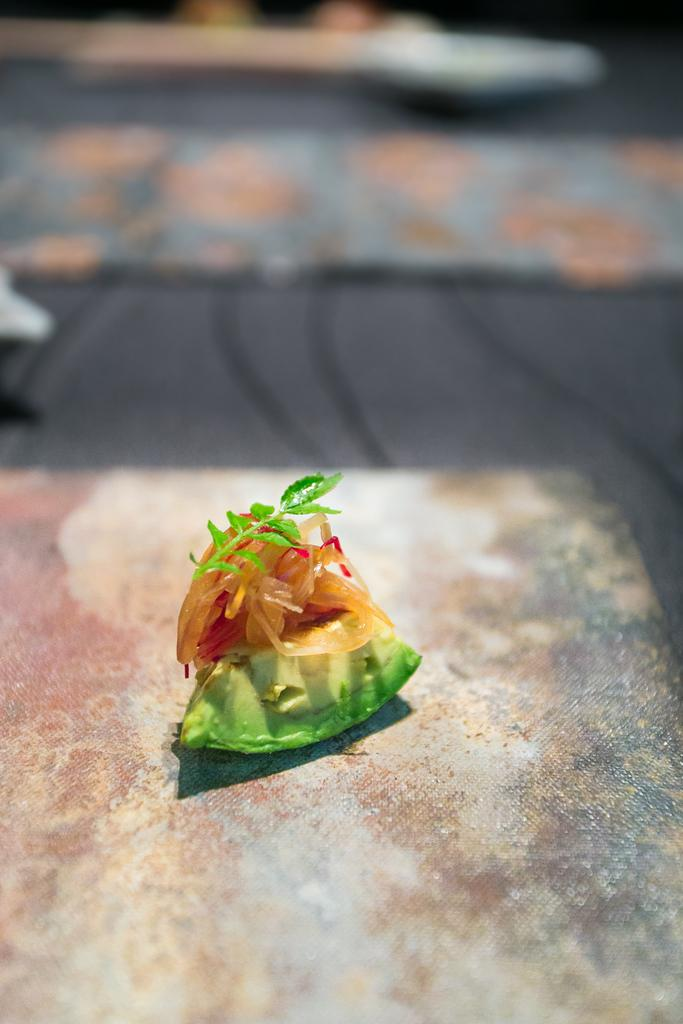What is the main object in the image? There is a stem with green leaves in the image. What is the stem attached to? The stem is on ingredients. What type of fruit is the stem and ingredients on? The stem and ingredients are on a fruit. Where is the fruit placed? The fruit is on a surface. Can you describe the background of the image? The background of the image is blurred. What is the price of the fruit in the image? There is no price information provided in the image. 